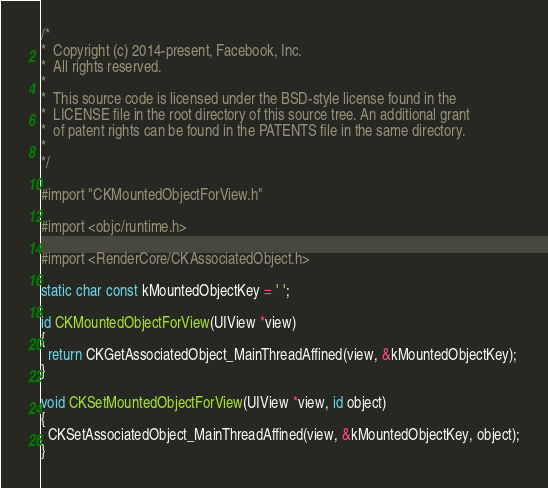Convert code to text. <code><loc_0><loc_0><loc_500><loc_500><_ObjectiveC_>/*
*  Copyright (c) 2014-present, Facebook, Inc.
*  All rights reserved.
*
*  This source code is licensed under the BSD-style license found in the
*  LICENSE file in the root directory of this source tree. An additional grant
*  of patent rights can be found in the PATENTS file in the same directory.
*
*/

#import "CKMountedObjectForView.h"

#import <objc/runtime.h>

#import <RenderCore/CKAssociatedObject.h>

static char const kMountedObjectKey = ' ';

id CKMountedObjectForView(UIView *view)
{
  return CKGetAssociatedObject_MainThreadAffined(view, &kMountedObjectKey);
}

void CKSetMountedObjectForView(UIView *view, id object)
{
  CKSetAssociatedObject_MainThreadAffined(view, &kMountedObjectKey, object);
}
</code> 